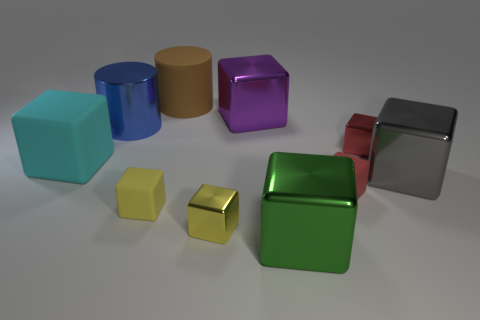There is a large block that is in front of the gray block; what material is it?
Your answer should be very brief. Metal. There is a purple metal object; are there any tiny red metal things in front of it?
Your answer should be very brief. Yes. There is a large purple object; what shape is it?
Provide a succinct answer. Cube. What number of objects are either cylinders that are in front of the purple cube or brown objects?
Ensure brevity in your answer.  2. How many other things are there of the same color as the matte cylinder?
Offer a very short reply. 0. There is another big rubber thing that is the same shape as the gray object; what color is it?
Make the answer very short. Cyan. Are the large purple thing and the yellow object on the left side of the yellow metallic cube made of the same material?
Offer a very short reply. No. What is the color of the matte cylinder?
Provide a succinct answer. Brown. The metal thing that is on the right side of the red thing behind the large object that is to the right of the large green metal cube is what color?
Your answer should be very brief. Gray. There is a big blue thing; is it the same shape as the big gray shiny thing that is in front of the brown object?
Keep it short and to the point. No. 